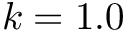Convert formula to latex. <formula><loc_0><loc_0><loc_500><loc_500>k = 1 . 0</formula> 